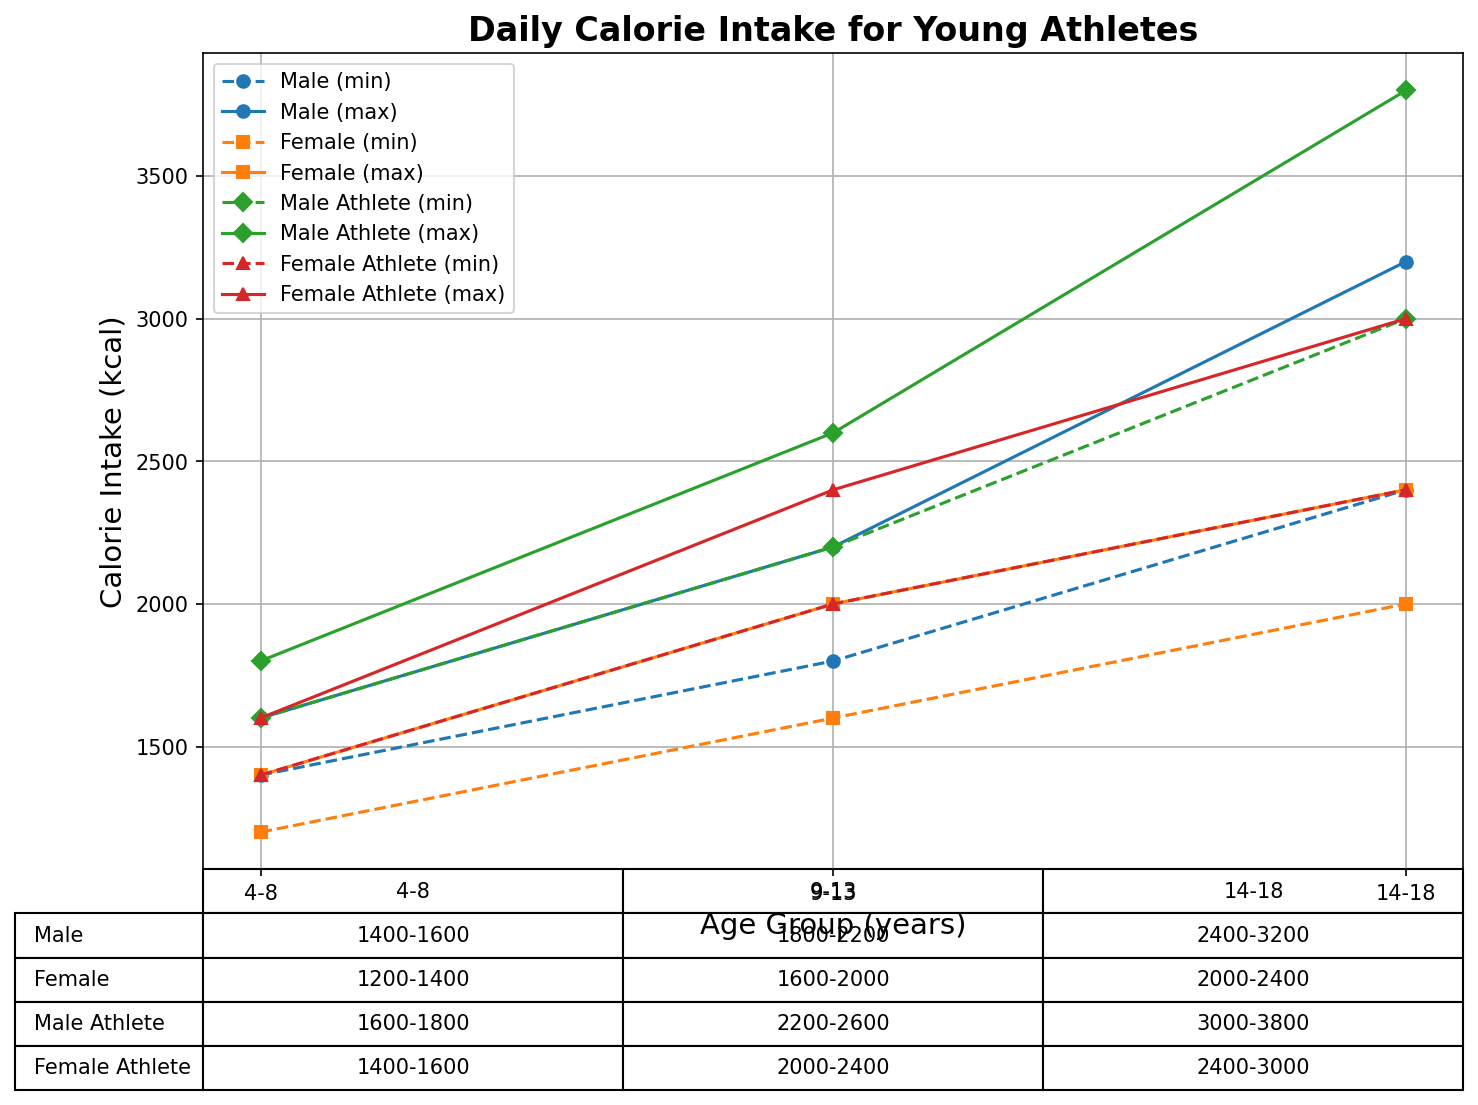What is the daily calorie intake range for male athletes aged 14-18? According to the table in the figure, the calorie intake range for male athletes aged 14-18 is listed as "3000-3800 kcal".
Answer: 3000-3800 kcal How does the maximum daily calorie intake for female athletes aged 9-13 compare with that of male athletes aged 9-13? The maximum daily calorie intake for female athletes aged 9-13 is 2400 kcal, while for male athletes of the same age, it is 2600 kcal.
Answer: 200 kcal less Which age group has the highest recommended daily calorie intake for non-athlete males? In the figure, the highest recommended daily calorie intake for non-athlete males is in the 14-18 age group, with a range of "2400-3200 kcal".
Answer: 14-18 years What is the calorie difference between the minimum intake for a 14-18 year old female athlete and a non-athlete female of the same age group? For a 14-18 year old female athlete, the minimum calorie intake is 2400 kcal, whereas for a non-athlete female of the same age it is 2000 kcal. The difference is 2400 - 2000 = 400 kcal.
Answer: 400 kcal What is the average of the maximum daily calorie intake across all groups for male athletes aged 14-18? The maximum daily calorie intake for male athletes aged 14-18 is 3800 kcal. Since there is only one value, the average is the same as the value itself, 3800 kcal.
Answer: 3800 kcal How does the calorie intake range change from male non-athletes aged 4-8 to aged 14-18? The calorie intake range for male non-athletes ages 4-8 is 1400-1600 kcal, and it increases to a range of 2400-3200 kcal for ages 14-18. So, the increase for the minimum intake is 2400 - 1400 = 1000 kcal, and for the maximum intake, it is 3200 - 1600 = 1600 kcal.
Answer: Increases by 1000-1600 kcal Which gender and age group has the lowest minimum daily calorie intake for athletes, according to the data? According to the data, the female athletes aged 4-8 have the lowest minimum daily calorie intake, which is 1400 kcal.
Answer: Female athletes aged 4-8 What is the maximum daily calorie intake difference between male athletes aged 9-13 and female non-athletes aged 14-18? The maximum daily calorie intake for male athletes aged 9-13 is 2600 kcal, and for female non-athletes aged 14-18, it is 2400 kcal. The difference is 2600 - 2400 = 200 kcal.
Answer: 200 kcal 